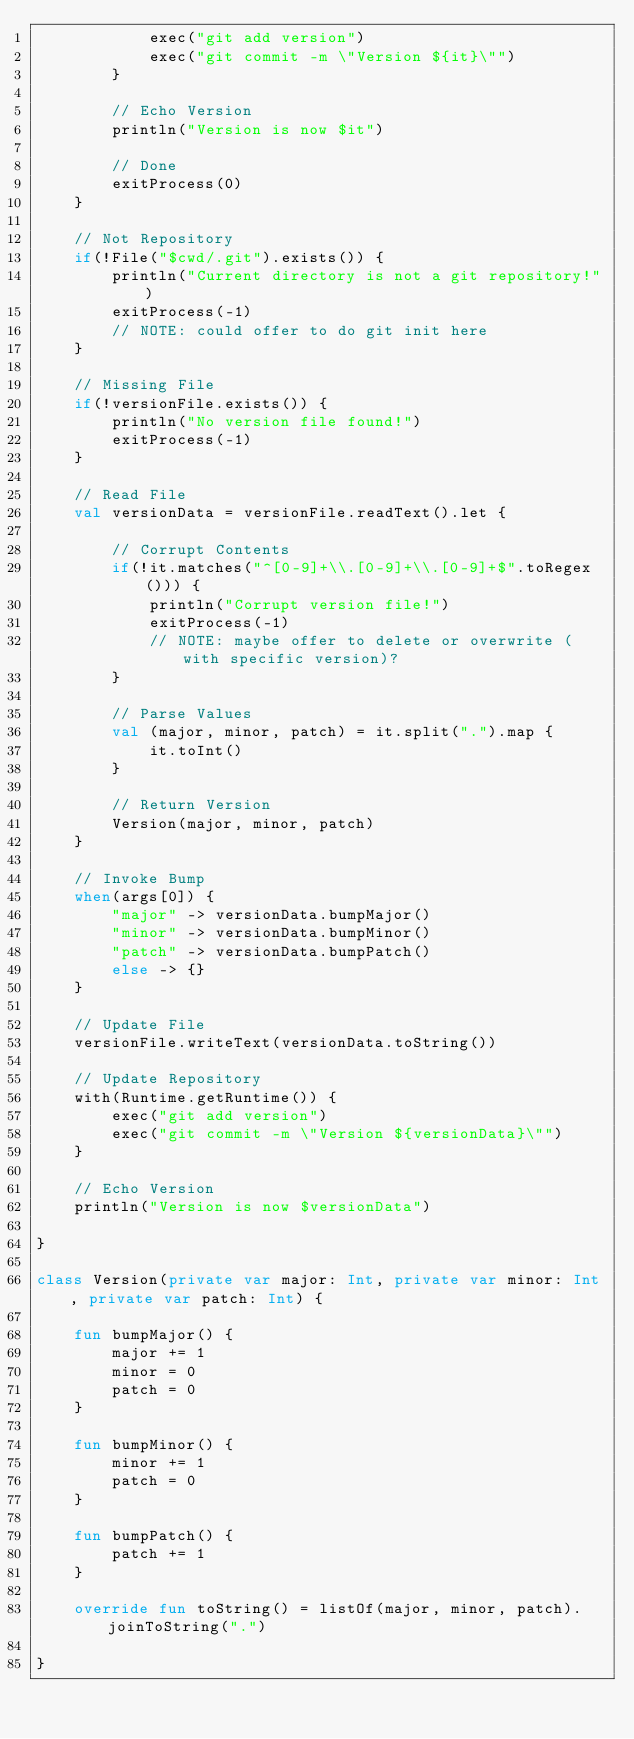<code> <loc_0><loc_0><loc_500><loc_500><_Kotlin_>            exec("git add version")
            exec("git commit -m \"Version ${it}\"")
        }

        // Echo Version
        println("Version is now $it")

        // Done
        exitProcess(0)
    }

    // Not Repository
    if(!File("$cwd/.git").exists()) {
        println("Current directory is not a git repository!")
        exitProcess(-1)
        // NOTE: could offer to do git init here
    }

    // Missing File
    if(!versionFile.exists()) {
        println("No version file found!")
        exitProcess(-1)
    }

    // Read File
    val versionData = versionFile.readText().let {

        // Corrupt Contents
        if(!it.matches("^[0-9]+\\.[0-9]+\\.[0-9]+$".toRegex())) {
            println("Corrupt version file!")
            exitProcess(-1)
            // NOTE: maybe offer to delete or overwrite (with specific version)?
        }

        // Parse Values
        val (major, minor, patch) = it.split(".").map {
            it.toInt()
        }

        // Return Version
        Version(major, minor, patch)
    }

    // Invoke Bump
    when(args[0]) {
        "major" -> versionData.bumpMajor()
        "minor" -> versionData.bumpMinor()
        "patch" -> versionData.bumpPatch()
        else -> {}
    }

    // Update File
    versionFile.writeText(versionData.toString())

    // Update Repository
    with(Runtime.getRuntime()) {
        exec("git add version")
        exec("git commit -m \"Version ${versionData}\"")
    }

    // Echo Version
    println("Version is now $versionData")

}

class Version(private var major: Int, private var minor: Int, private var patch: Int) {

    fun bumpMajor() {
        major += 1
        minor = 0
        patch = 0
    }

    fun bumpMinor() {
        minor += 1
        patch = 0
    }

    fun bumpPatch() {
        patch += 1
    }

    override fun toString() = listOf(major, minor, patch).joinToString(".")

}</code> 